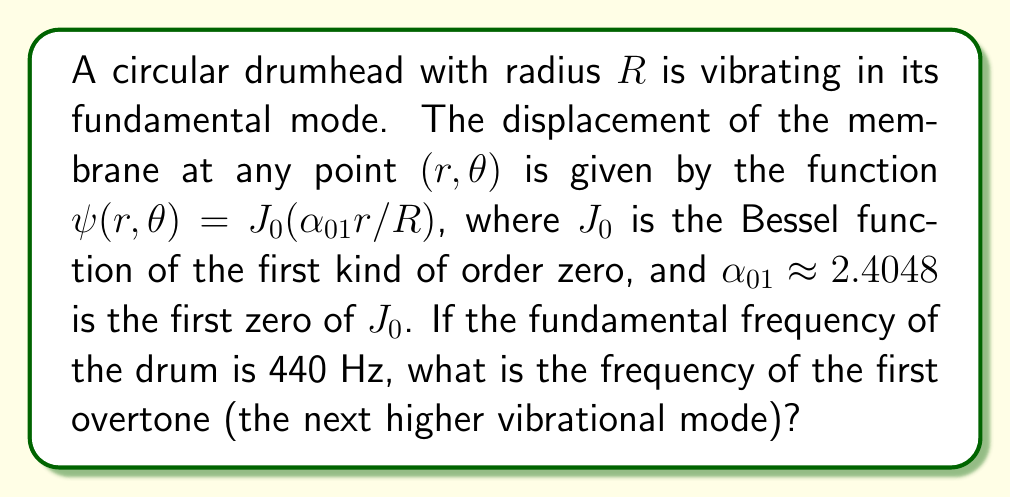What is the answer to this math problem? To solve this problem, we need to follow these steps:

1) First, recall that for a circular membrane, the frequencies of the vibrational modes are proportional to the zeros of the Bessel function $J_0$. The fundamental frequency corresponds to the first zero, $\alpha_{01} \approx 2.4048$.

2) The next higher mode (first overtone) corresponds to the second zero of $J_0$, which is $\alpha_{02} \approx 5.5201$.

3) The frequencies of the modes are proportional to these zeros. So, if we call the fundamental frequency $f_1$ and the first overtone $f_2$, we can write:

   $$\frac{f_2}{f_1} = \frac{\alpha_{02}}{\alpha_{01}}$$

4) We're given that $f_1 = 440$ Hz. Let's substitute this and the values of $\alpha_{01}$ and $\alpha_{02}$:

   $$\frac{f_2}{440} = \frac{5.5201}{2.4048}$$

5) Now we can solve for $f_2$:

   $$f_2 = 440 \cdot \frac{5.5201}{2.4048} \approx 1009.1 \text{ Hz}$$

6) Rounding to the nearest whole number, we get 1009 Hz.

This higher frequency would produce a noticeably higher pitch, which a skilled percussionist would need to be aware of when tuning and playing the drum.
Answer: 1009 Hz 